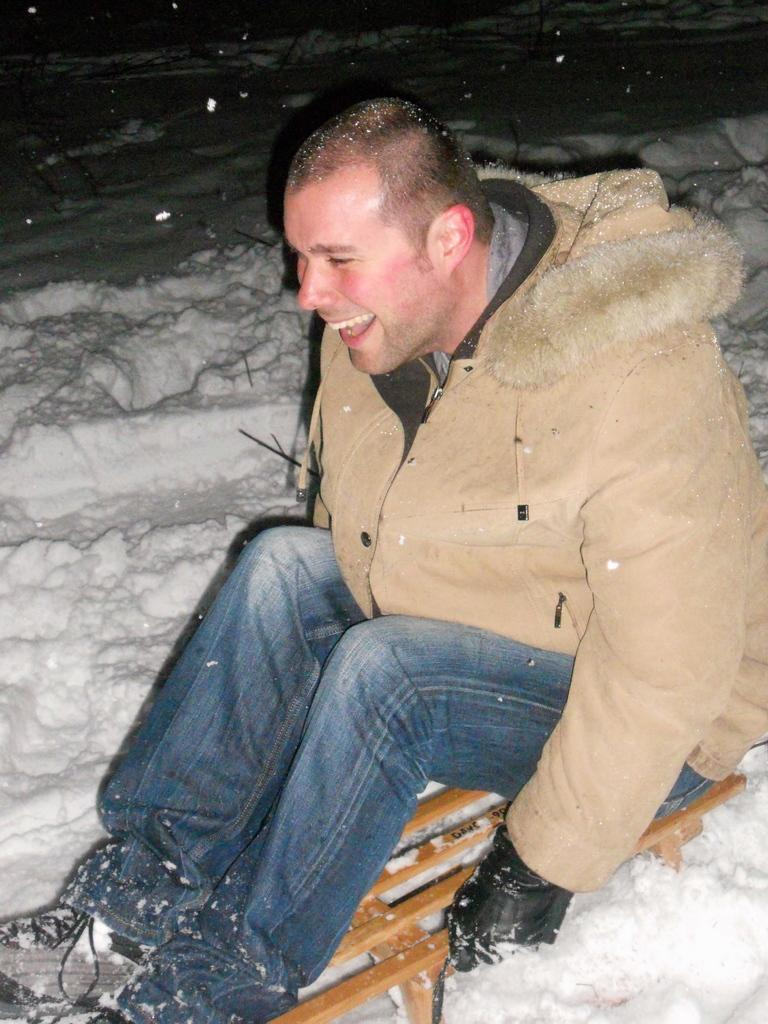What is the main subject of the image? There is a person sitting in the image. What is the person sitting on? The person is sitting on a brown object. What type of weather is depicted in the image? There is snow visible in the image. Can you see any animals from the zoo in the image? There are no animals from a zoo present in the image. What type of sun is shining in the image? There is no sun visible in the image, as it is snowing. 